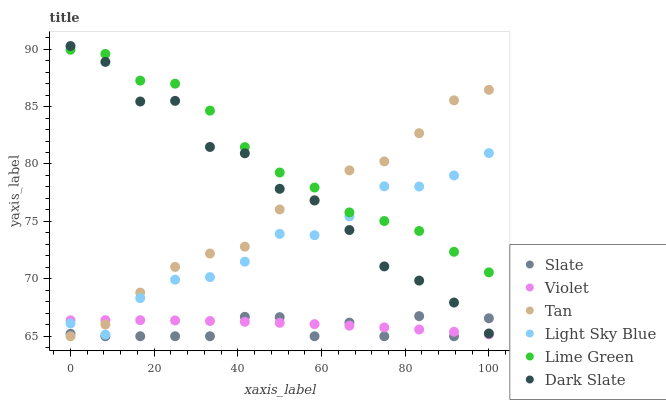Does Slate have the minimum area under the curve?
Answer yes or no. Yes. Does Lime Green have the maximum area under the curve?
Answer yes or no. Yes. Does Dark Slate have the minimum area under the curve?
Answer yes or no. No. Does Dark Slate have the maximum area under the curve?
Answer yes or no. No. Is Violet the smoothest?
Answer yes or no. Yes. Is Dark Slate the roughest?
Answer yes or no. Yes. Is Light Sky Blue the smoothest?
Answer yes or no. No. Is Light Sky Blue the roughest?
Answer yes or no. No. Does Slate have the lowest value?
Answer yes or no. Yes. Does Dark Slate have the lowest value?
Answer yes or no. No. Does Dark Slate have the highest value?
Answer yes or no. Yes. Does Light Sky Blue have the highest value?
Answer yes or no. No. Is Violet less than Dark Slate?
Answer yes or no. Yes. Is Light Sky Blue greater than Slate?
Answer yes or no. Yes. Does Dark Slate intersect Slate?
Answer yes or no. Yes. Is Dark Slate less than Slate?
Answer yes or no. No. Is Dark Slate greater than Slate?
Answer yes or no. No. Does Violet intersect Dark Slate?
Answer yes or no. No. 